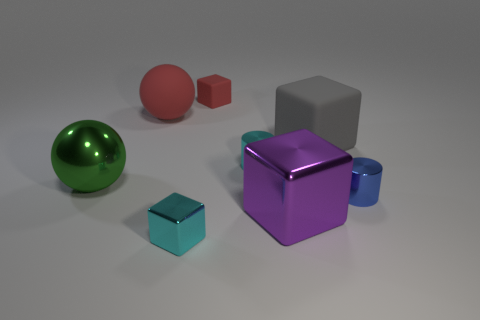The tiny metallic object that is the same color as the small metal block is what shape?
Your answer should be compact. Cylinder. What is the size of the matte object that is the same color as the small rubber block?
Your response must be concise. Large. Are there fewer large purple shiny cubes than blocks?
Provide a succinct answer. Yes. There is a large green thing; is its shape the same as the red matte object that is in front of the small red thing?
Your response must be concise. Yes. There is a large object that is both in front of the small cyan cylinder and behind the tiny blue metal thing; what shape is it?
Your answer should be compact. Sphere. Are there an equal number of small cyan cylinders that are in front of the small cyan metal cylinder and cubes that are to the right of the small cyan block?
Provide a succinct answer. No. There is a tiny metallic object in front of the tiny blue metallic object; is it the same shape as the big purple metal thing?
Offer a very short reply. Yes. What number of red things are rubber spheres or small matte blocks?
Your response must be concise. 2. What is the material of the cyan object that is the same shape as the purple shiny thing?
Provide a short and direct response. Metal. The cyan metal object on the left side of the red rubber block has what shape?
Your answer should be compact. Cube. 